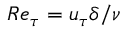Convert formula to latex. <formula><loc_0><loc_0><loc_500><loc_500>R e _ { \tau } = u _ { \tau } \delta / \nu</formula> 